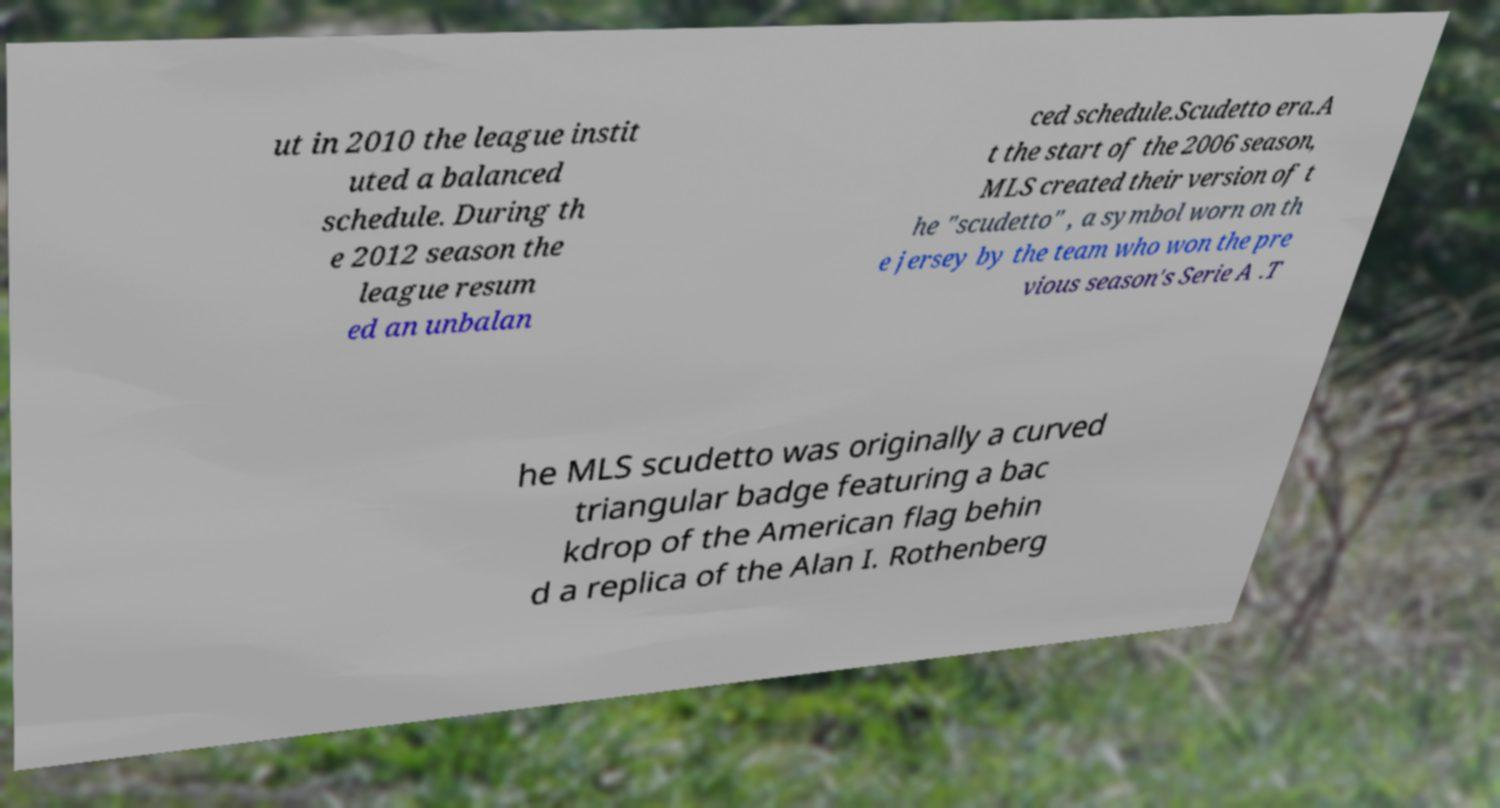Could you extract and type out the text from this image? ut in 2010 the league instit uted a balanced schedule. During th e 2012 season the league resum ed an unbalan ced schedule.Scudetto era.A t the start of the 2006 season, MLS created their version of t he "scudetto" , a symbol worn on th e jersey by the team who won the pre vious season's Serie A .T he MLS scudetto was originally a curved triangular badge featuring a bac kdrop of the American flag behin d a replica of the Alan I. Rothenberg 